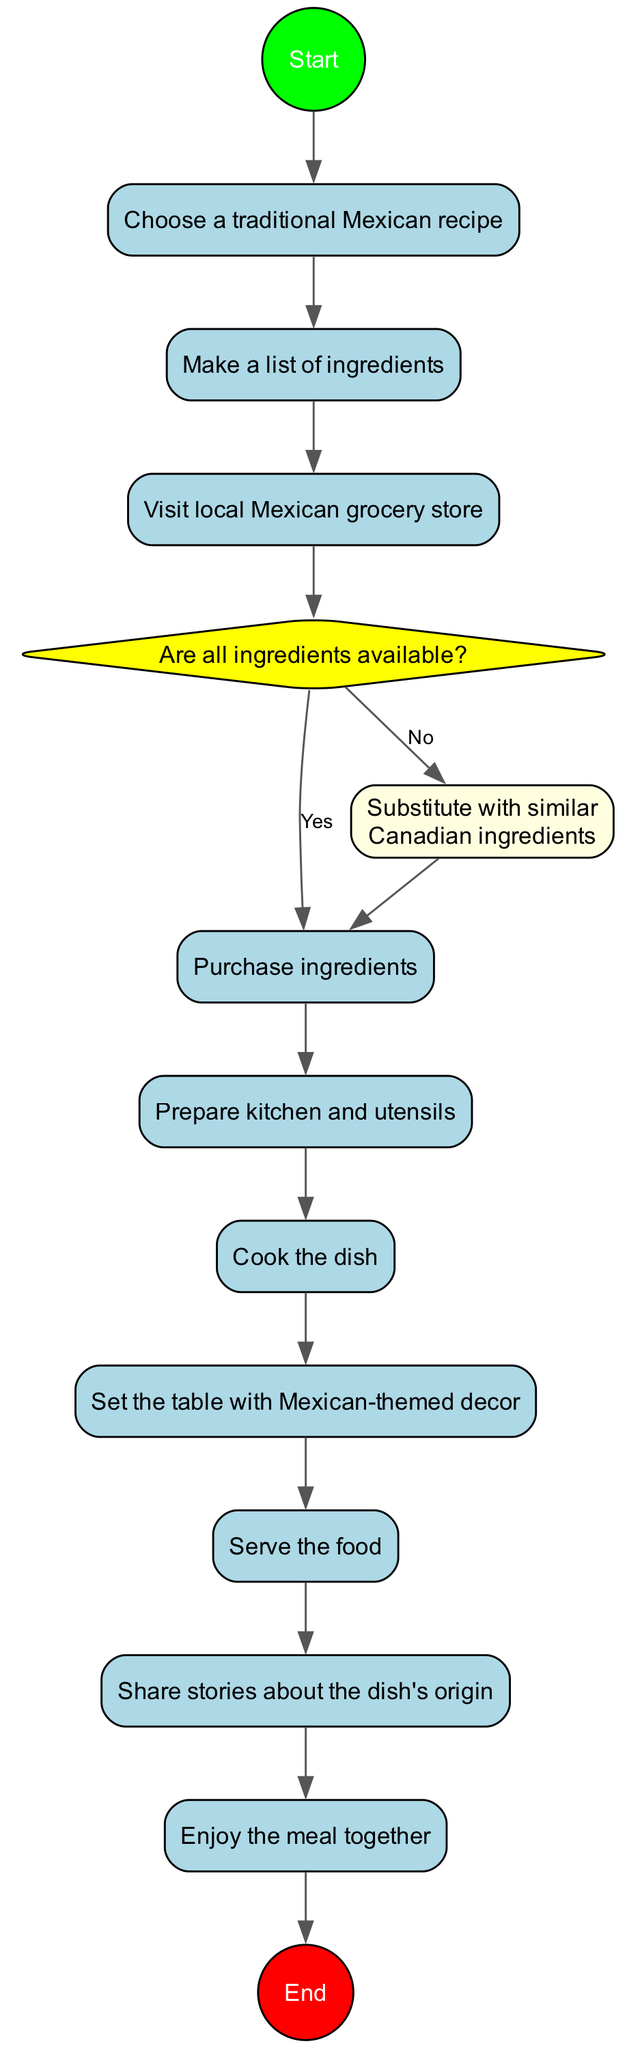What is the first activity in the diagram? The first activity node after the start is "Choose a traditional Mexican recipe," which immediately follows the Start node in the flow.
Answer: Choose a traditional Mexican recipe How many activities are there in total? There are ten activities listed in the activities section of the diagram. This total includes all steps from the beginning to just before the end node.
Answer: 10 What happens if all ingredients are available? If all ingredients are available, the flow proceeds directly to the "Prepare kitchen and utensils" activity after the decision node. This is indicated by the 'Yes' pathway connected from the decision node.
Answer: Prepare kitchen and utensils What is the decision point in the diagram? The decision point in the diagram is whether all ingredients are available or not. This is indicated by the diamond-shaped node that presents a question regarding the availability of ingredients.
Answer: Are all ingredients available? What activity follows after "Cook the dish"? After "Cook the dish," the next activity is "Set the table with Mexican-themed decor," which is the sequential step that follows in the flow of the diagram.
Answer: Set the table with Mexican-themed decor If the answer to the decision question is 'No', what action is taken? If the answer is 'No' to the decision question, the action taken is to "Substitute with similar Canadian ingredients," which is defined by an alternate path stemming from the decision node.
Answer: Substitute with similar Canadian ingredients How does the activity "Share stories about the dish's origin" relate to the previous activity? "Share stories about the dish's origin" follows immediately after "Serve the food" in a linear sequence within the flow of the diagram, establishing them as consecutive actions.
Answer: It follows "Serve the food" What is the final node represented in the diagram? The final node represented in the diagram is "End," which signifies the completion of the process after enjoying the meal together and serves as the last step in the flow.
Answer: End 